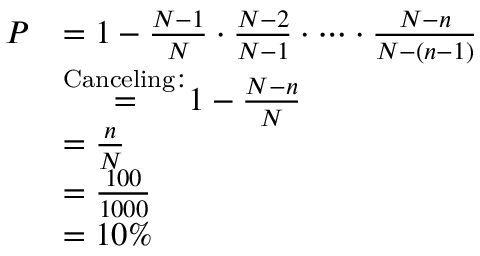<formula> <loc_0><loc_0><loc_500><loc_500>{ \begin{array} { r l } { P } & { = 1 - { \frac { N - 1 } { N } } \cdot { \frac { N - 2 } { N - 1 } } \cdot \cdots \cdot { \frac { N - n } { N - ( n - 1 ) } } } \\ & { { \stackrel { C a n c e l i n g \colon } { = } } 1 - { \frac { N - n } { N } } } \\ & { = { \frac { n } { N } } } \\ & { = { \frac { 1 0 0 } { 1 0 0 0 } } } \\ & { = 1 0 \% } \end{array} }</formula> 